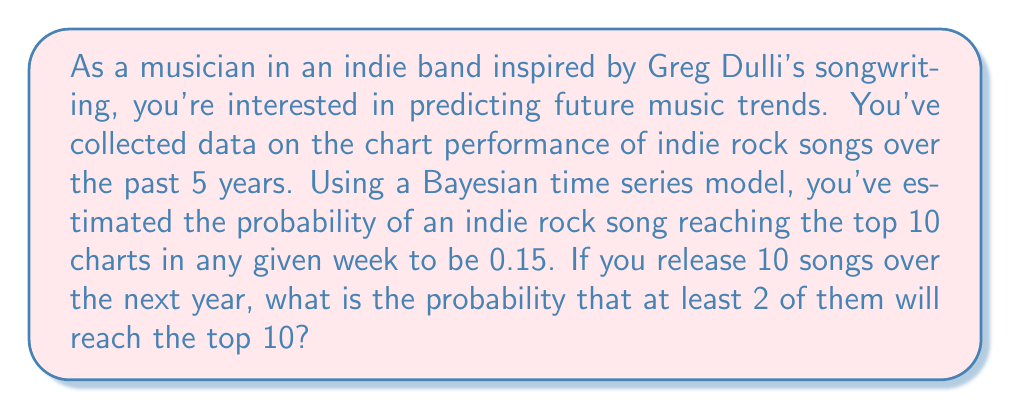Help me with this question. To solve this problem, we'll use the Binomial distribution and the concept of cumulative probability.

1) Let X be the number of songs that reach the top 10 out of 10 released songs.
   X follows a Binomial distribution with n = 10 and p = 0.15

2) We want to find P(X ≥ 2), which is equivalent to 1 - P(X < 2) or 1 - P(X ≤ 1)

3) The probability mass function for a Binomial distribution is:

   $$P(X = k) = \binom{n}{k} p^k (1-p)^{n-k}$$

4) We need to calculate:

   $$1 - [P(X = 0) + P(X = 1)]$$

5) Calculating P(X = 0):
   $$P(X = 0) = \binom{10}{0} 0.15^0 (1-0.15)^{10} = 1 \cdot 1 \cdot 0.85^{10} \approx 0.1969$$

6) Calculating P(X = 1):
   $$P(X = 1) = \binom{10}{1} 0.15^1 (1-0.15)^9 = 10 \cdot 0.15 \cdot 0.85^9 \approx 0.3474$$

7) Therefore, the probability of at least 2 songs reaching the top 10 is:
   $$1 - (0.1969 + 0.3474) = 1 - 0.5443 = 0.4557$$
Answer: The probability that at least 2 out of 10 songs will reach the top 10 charts is approximately 0.4557 or 45.57%. 